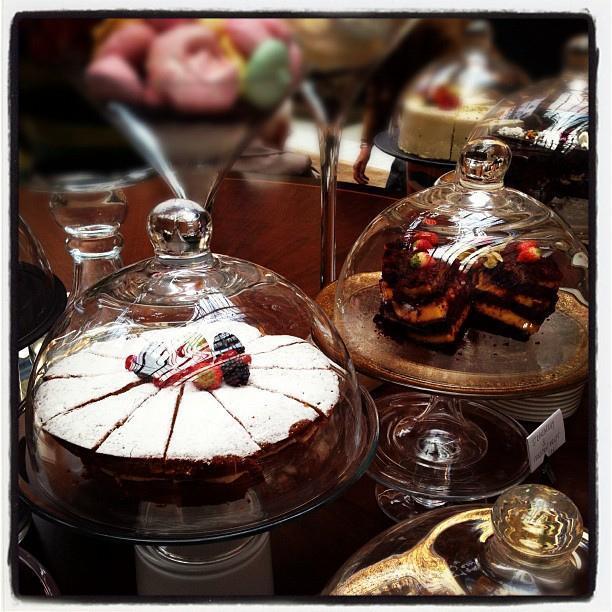How many cakes are there?
Give a very brief answer. 4. How many boats are there?
Give a very brief answer. 0. 